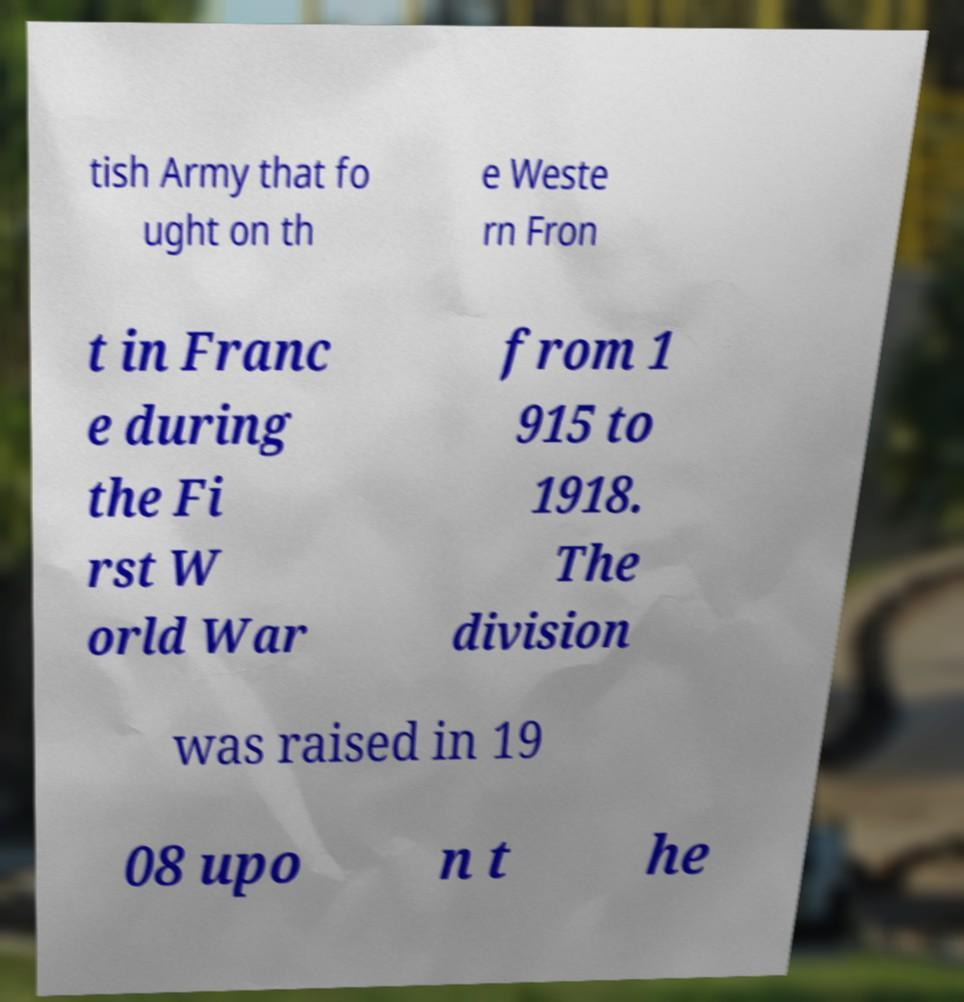I need the written content from this picture converted into text. Can you do that? tish Army that fo ught on th e Weste rn Fron t in Franc e during the Fi rst W orld War from 1 915 to 1918. The division was raised in 19 08 upo n t he 